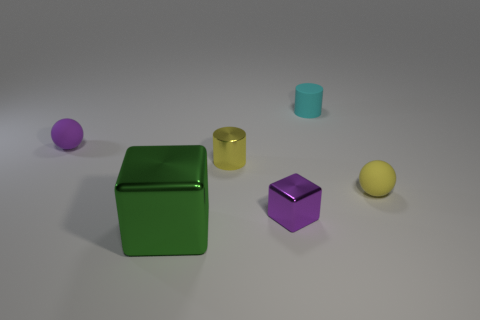Are there any large green cubes that have the same material as the small block?
Provide a succinct answer. Yes. What size is the matte object that is the same color as the small block?
Keep it short and to the point. Small. What number of yellow things are either small objects or big matte cubes?
Offer a very short reply. 2. Is there another large metal object of the same color as the big object?
Give a very brief answer. No. What is the size of the cylinder that is the same material as the tiny yellow sphere?
Offer a terse response. Small. How many balls are cyan objects or metal objects?
Your answer should be very brief. 0. Is the number of cyan balls greater than the number of things?
Offer a very short reply. No. How many yellow matte objects are the same size as the purple rubber thing?
Make the answer very short. 1. How many things are either rubber things that are to the left of the big thing or large green shiny things?
Ensure brevity in your answer.  2. Are there fewer large brown matte spheres than metallic cubes?
Offer a very short reply. Yes. 